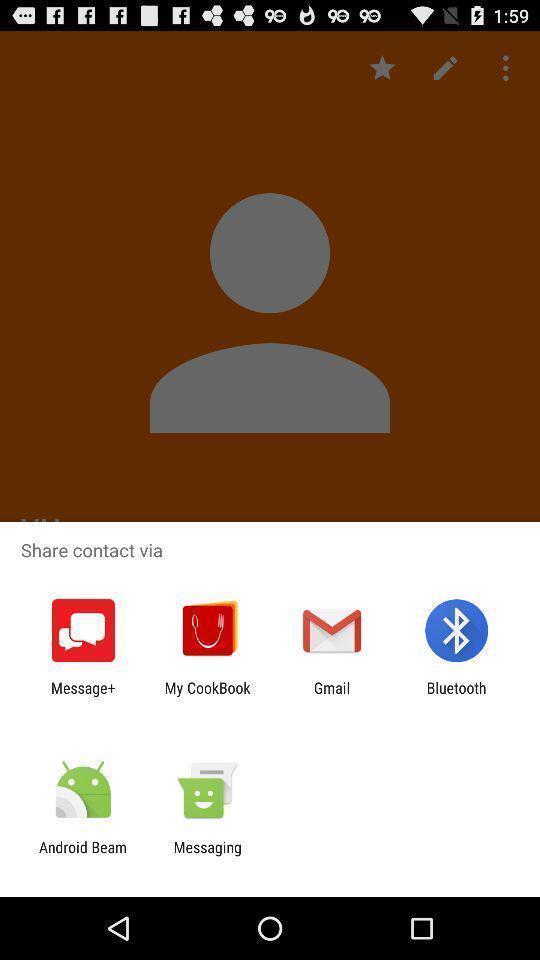Explain what's happening in this screen capture. Share contact with different apps. 